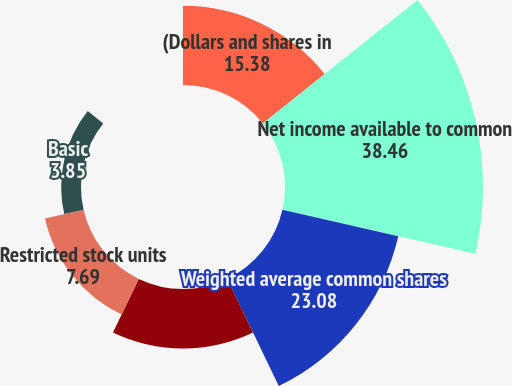<chart> <loc_0><loc_0><loc_500><loc_500><pie_chart><fcel>(Dollars and shares in<fcel>Net income available to common<fcel>Weighted average common shares<fcel>Stock options and ESPP<fcel>Restricted stock units<fcel>Basic<fcel>Diluted<nl><fcel>15.38%<fcel>38.46%<fcel>23.08%<fcel>11.54%<fcel>7.69%<fcel>3.85%<fcel>0.0%<nl></chart> 